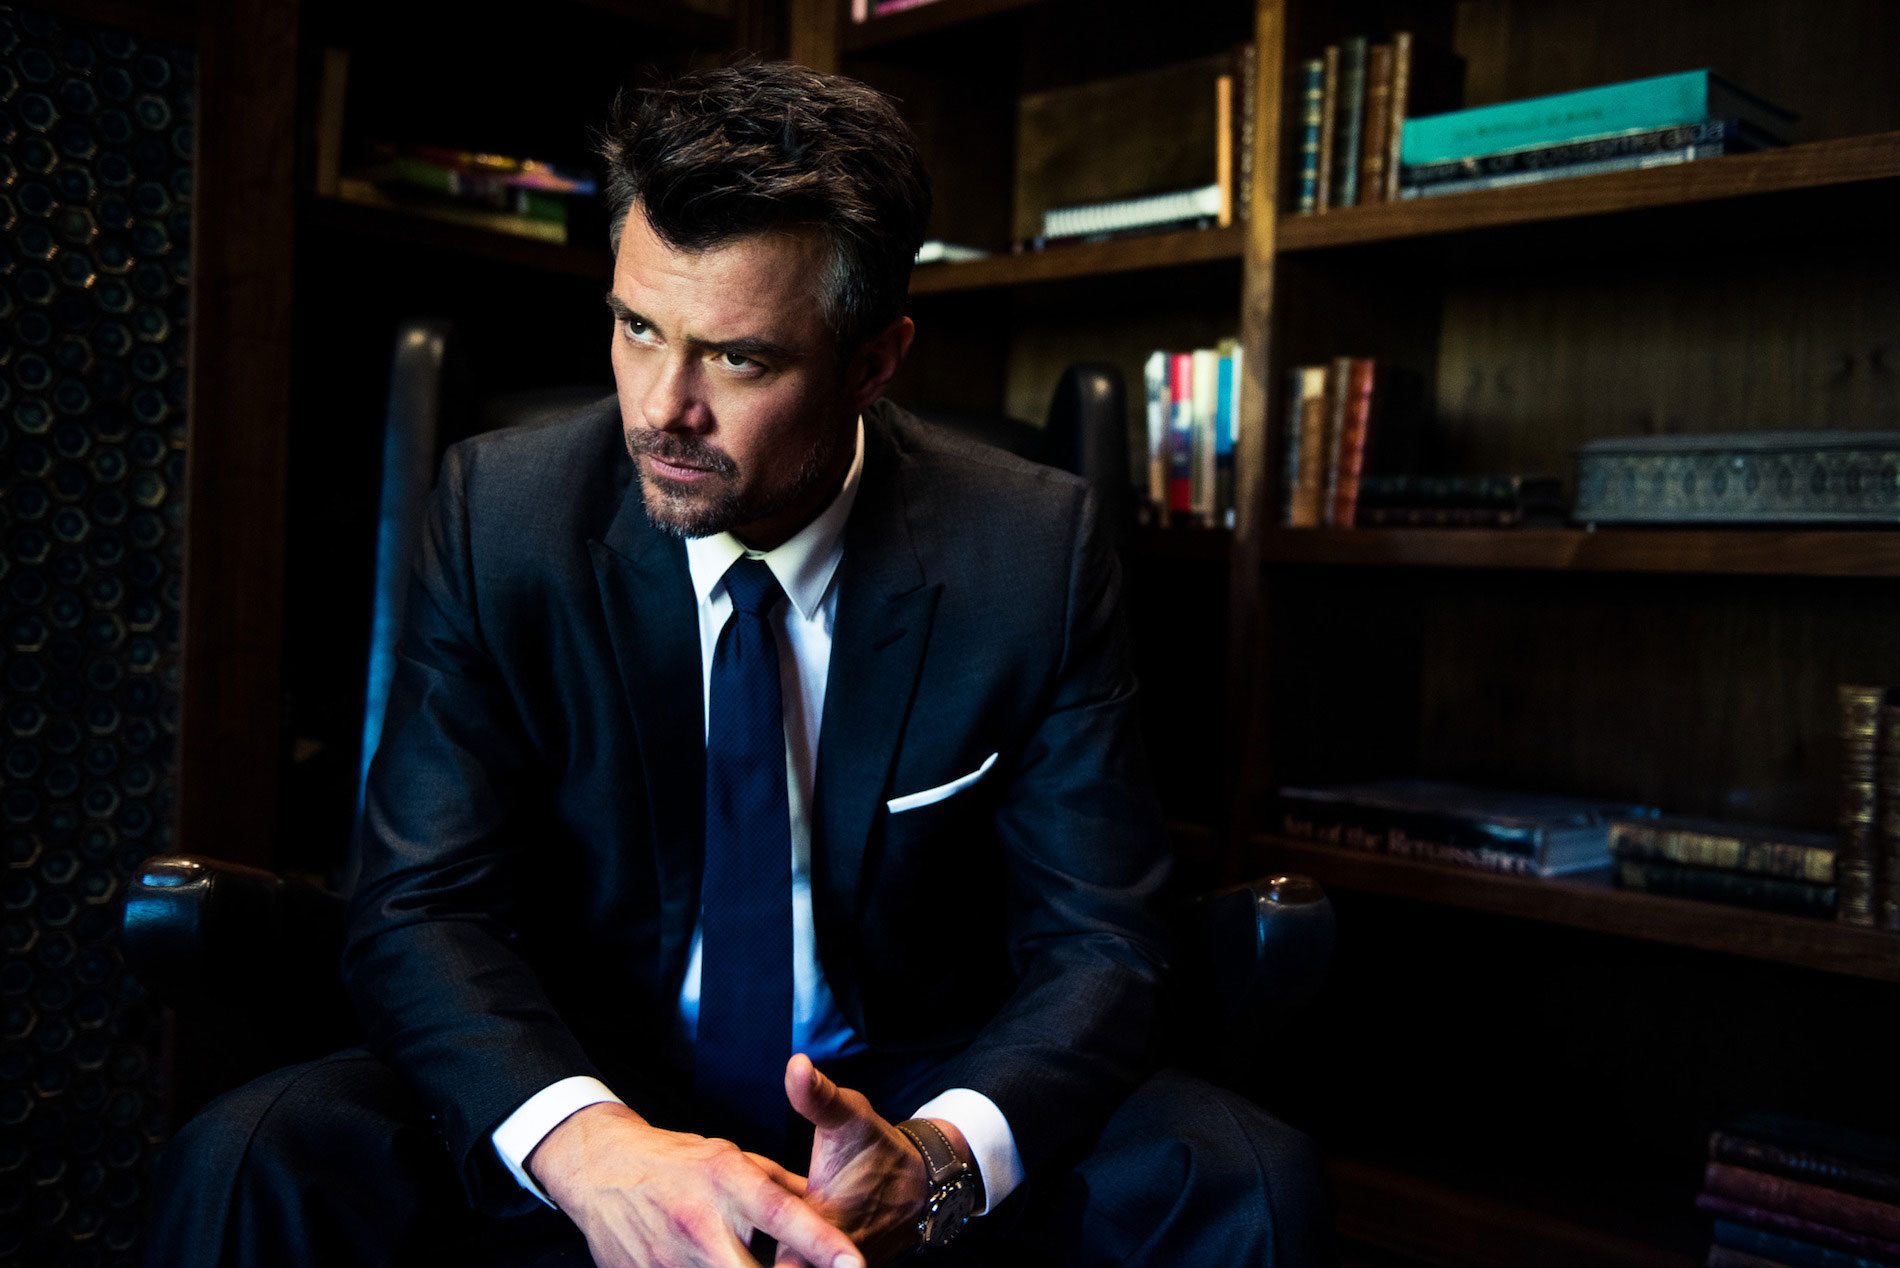Can you describe the environment the person is in? The environment appears to be a study or a library, given the presence of numerous bookshelves filled with books and decorative items. The dim lighting and the rich wooden tones of the furniture and shelving suggest a sophisticated, possibly professional setting. How do you think the lighting affects the mood of the image? The dim lighting contributes significantly to the mood of the image, enhancing the pensive and introspective atmosphere. Shadows and highlights frame the scene, focusing attention on the man's thoughtful expression and the overall somber tone of the room. If this were a scene from a movie, what genre would it likely belong to? If this image were a scene from a movie, it would likely belong to the drama or thriller genre. The serious and contemplative nature of the scene, along with the dim lighting and formal setting, fits well within the narrative styles of these genres. In terms of color and composition, how would you describe this image as an artwork? As an artwork, this image uses a muted color palette dominated by dark blues, blacks, and browns, which create a somber and reflective mood. The composition is carefully framed, with the man placed centrally to draw the viewer’s focus. The diagonal lines created by his posture and the angle of the light add dynamic tension, contributing to the overall atmosphere of introspection. 